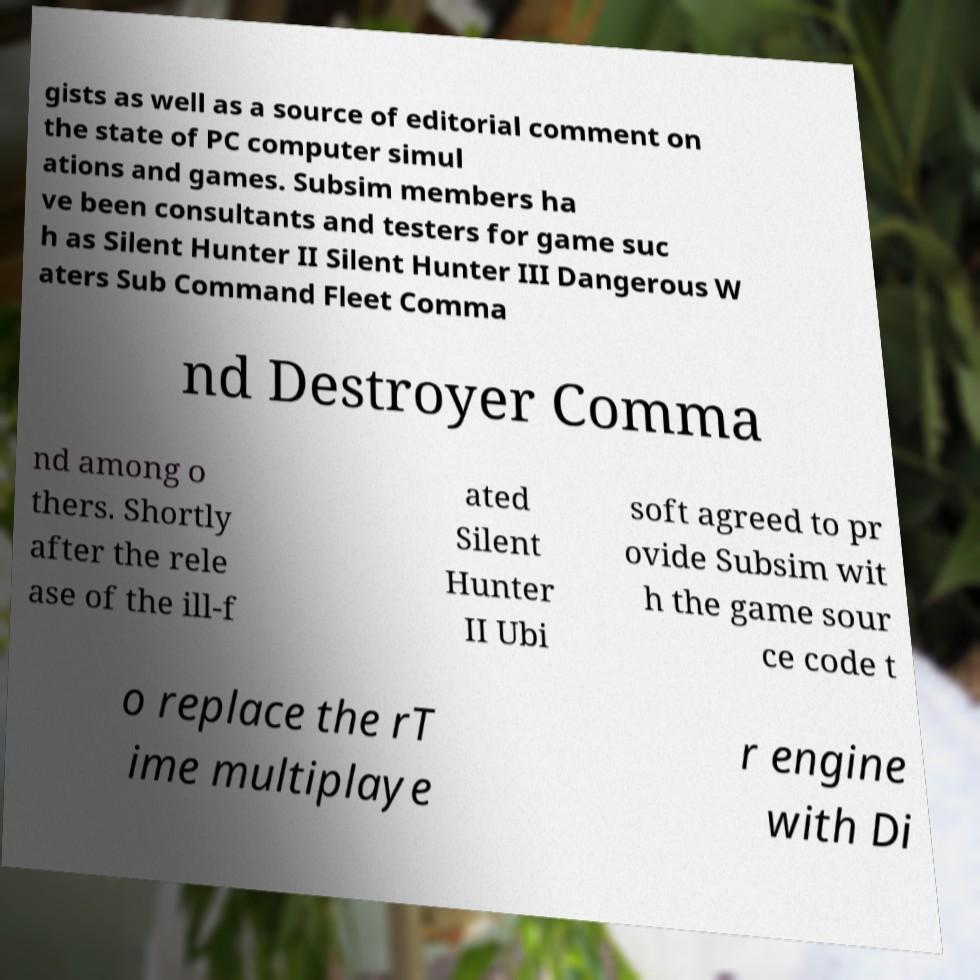For documentation purposes, I need the text within this image transcribed. Could you provide that? gists as well as a source of editorial comment on the state of PC computer simul ations and games. Subsim members ha ve been consultants and testers for game suc h as Silent Hunter II Silent Hunter III Dangerous W aters Sub Command Fleet Comma nd Destroyer Comma nd among o thers. Shortly after the rele ase of the ill-f ated Silent Hunter II Ubi soft agreed to pr ovide Subsim wit h the game sour ce code t o replace the rT ime multiplaye r engine with Di 